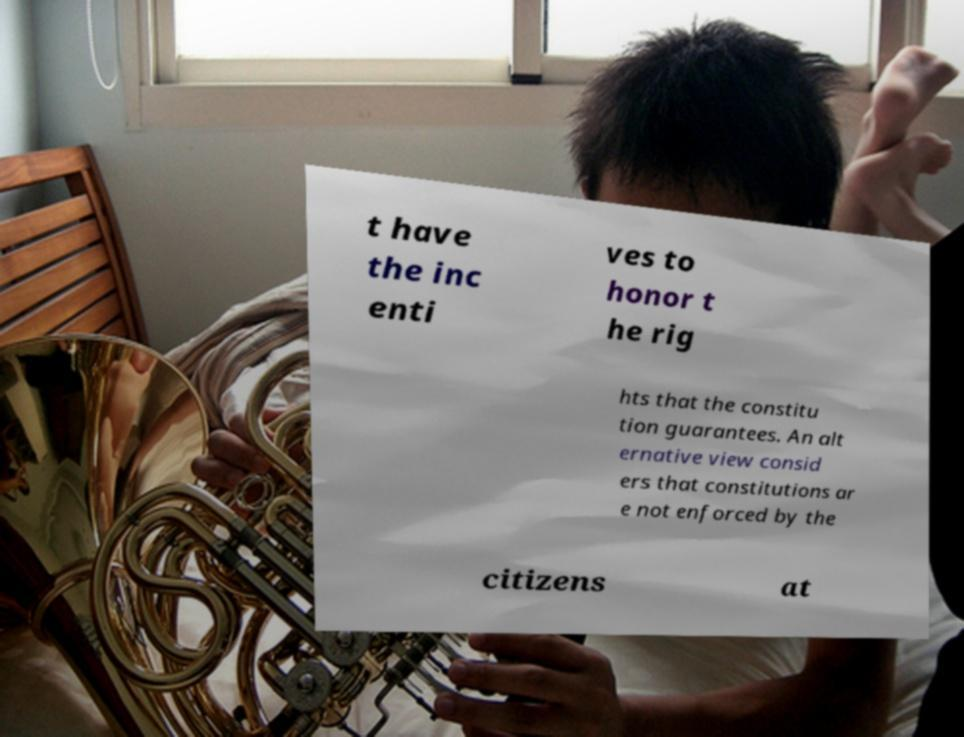Please identify and transcribe the text found in this image. t have the inc enti ves to honor t he rig hts that the constitu tion guarantees. An alt ernative view consid ers that constitutions ar e not enforced by the citizens at 